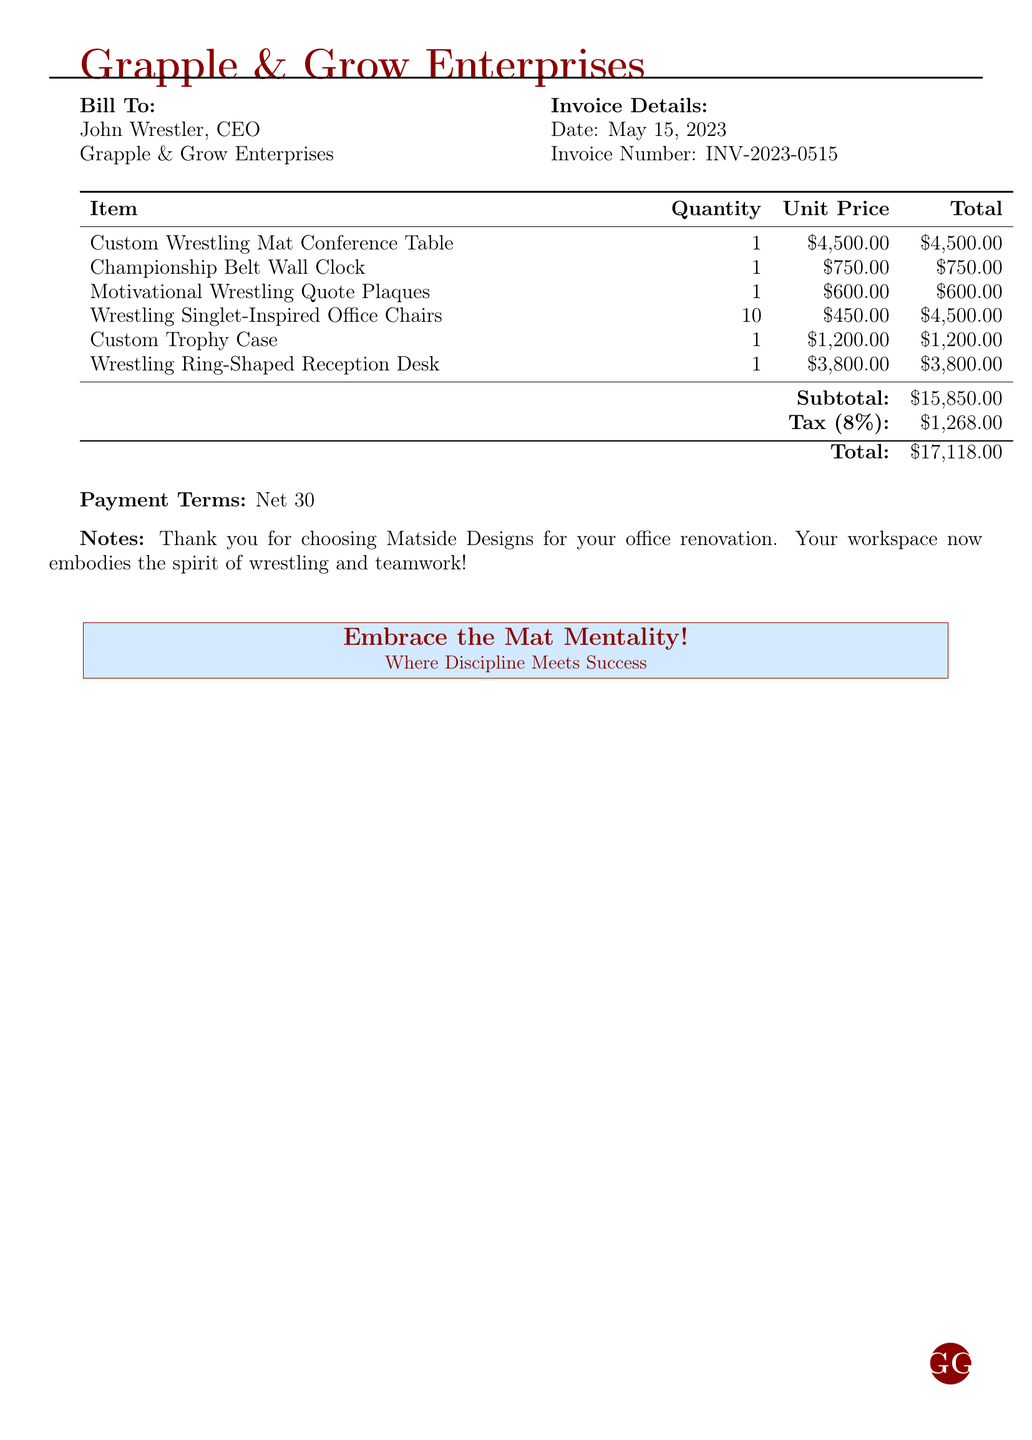What is the invoice number? The invoice number is provided in the document under Invoice Details, it helps in tracking the bill.
Answer: INV-2023-0515 What is the date of the invoice? The date of the invoice can be found in the Invoice Details section, indicating when the bill was issued.
Answer: May 15, 2023 How many wrestling singlet-inspired office chairs are included? The quantity of wrestling singlet-inspired office chairs is listed in the itemized table of the document.
Answer: 10 What is the subtotal amount before tax? The subtotal is the total of all item prices listed, before any taxes are applied.
Answer: $15,850.00 What is the tax percentage applied to the bill? The tax percentage is indicated in the document, showing how tax is calculated on the subtotal.
Answer: 8% What is the total amount due? The total amount includes the subtotal and tax, and is the final bill amount that is to be paid.
Answer: $17,118.00 What payment terms are specified in the document? The payment terms outline when the payment is due after receiving the invoice.
Answer: Net 30 Who is the bill addressed to? The recipient of the invoice is specified at the beginning of the document under Bill To.
Answer: John Wrestler, CEO What type of furniture is the conference table modeled after? The description of the conference table in the itemized list specifies its design inspiration.
Answer: Wrestling Mat What does the note at the bottom of the bill thank the customer for? The note expresses gratitude for using the services of the company creating the furniture.
Answer: Office renovation 